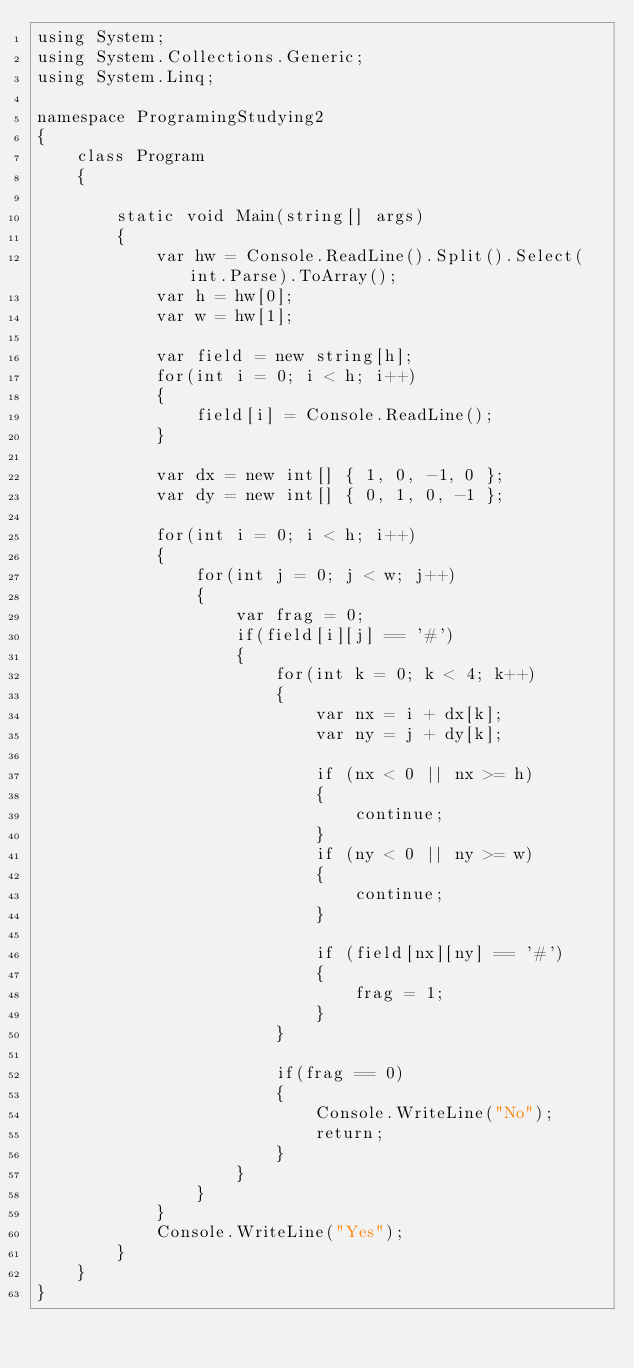Convert code to text. <code><loc_0><loc_0><loc_500><loc_500><_C#_>using System;
using System.Collections.Generic;
using System.Linq;

namespace ProgramingStudying2
{
    class Program
    {

        static void Main(string[] args)
        {
            var hw = Console.ReadLine().Split().Select(int.Parse).ToArray();
            var h = hw[0];
            var w = hw[1];
            
            var field = new string[h];
            for(int i = 0; i < h; i++)
            {
                field[i] = Console.ReadLine();
            }

            var dx = new int[] { 1, 0, -1, 0 };
            var dy = new int[] { 0, 1, 0, -1 };

            for(int i = 0; i < h; i++)
            {
                for(int j = 0; j < w; j++)
                {
                    var frag = 0;
                    if(field[i][j] == '#')
                    {
                        for(int k = 0; k < 4; k++)
                        {
                            var nx = i + dx[k];
                            var ny = j + dy[k];

                            if (nx < 0 || nx >= h)
                            {
                                continue;
                            }
                            if (ny < 0 || ny >= w)
                            {
                                continue;
                            }

                            if (field[nx][ny] == '#') 
                            {
                                frag = 1;
                            }
                        }

                        if(frag == 0)
                        {
                            Console.WriteLine("No");
                            return;
                        }
                    }
                }
            }
            Console.WriteLine("Yes");
        }
    }
}
</code> 